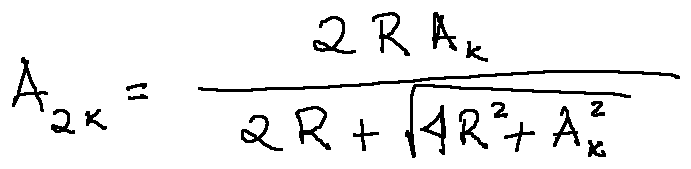Convert formula to latex. <formula><loc_0><loc_0><loc_500><loc_500>A _ { 2 k } = \frac { 2 R A _ { k } } { 2 R + \sqrt { 4 R ^ { 2 } + A _ { k } ^ { 2 } } }</formula> 